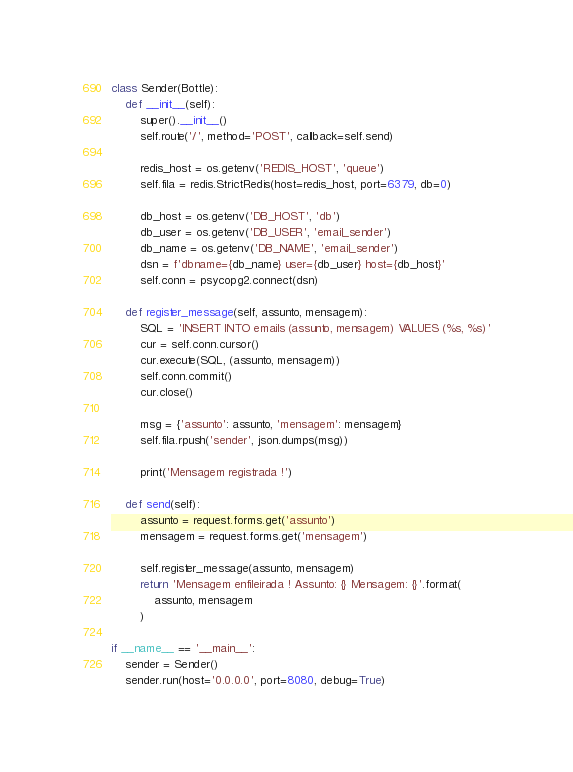<code> <loc_0><loc_0><loc_500><loc_500><_Python_>
class Sender(Bottle):
    def __init__(self):
        super().__init__()
        self.route('/', method='POST', callback=self.send)
        
        redis_host = os.getenv('REDIS_HOST', 'queue')
        self.fila = redis.StrictRedis(host=redis_host, port=6379, db=0)

        db_host = os.getenv('DB_HOST', 'db')
        db_user = os.getenv('DB_USER', 'email_sender')
        db_name = os.getenv('DB_NAME', 'email_sender')
        dsn = f'dbname={db_name} user={db_user} host={db_host}'
        self.conn = psycopg2.connect(dsn)
        
    def register_message(self, assunto, mensagem):
        SQL = 'INSERT INTO emails (assunto, mensagem) VALUES (%s, %s)'
        cur = self.conn.cursor()
        cur.execute(SQL, (assunto, mensagem))
        self.conn.commit()
        cur.close()

        msg = {'assunto': assunto, 'mensagem': mensagem}
        self.fila.rpush('sender', json.dumps(msg))

        print('Mensagem registrada !')

    def send(self):
        assunto = request.forms.get('assunto')
        mensagem = request.forms.get('mensagem')

        self.register_message(assunto, mensagem)
        return 'Mensagem enfileirada ! Assunto: {} Mensagem: {}'.format(
            assunto, mensagem
        )

if __name__ == '__main__':
    sender = Sender()
    sender.run(host='0.0.0.0', port=8080, debug=True)</code> 